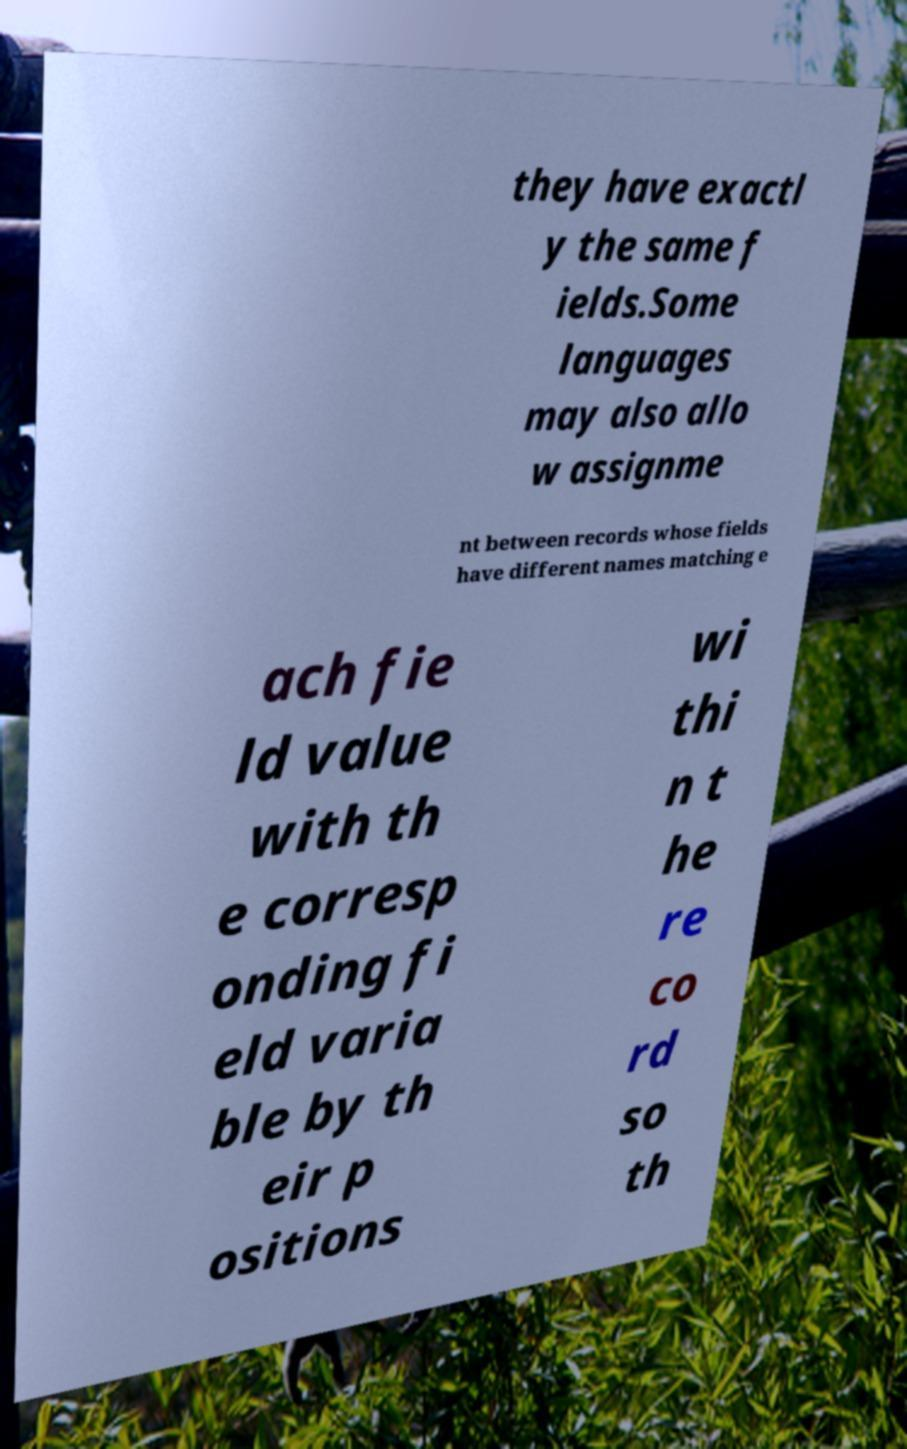Could you assist in decoding the text presented in this image and type it out clearly? they have exactl y the same f ields.Some languages may also allo w assignme nt between records whose fields have different names matching e ach fie ld value with th e corresp onding fi eld varia ble by th eir p ositions wi thi n t he re co rd so th 